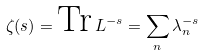<formula> <loc_0><loc_0><loc_500><loc_500>\zeta ( s ) = \text {Tr} \, L ^ { - s } = \sum _ { n } \lambda _ { n } ^ { - s }</formula> 